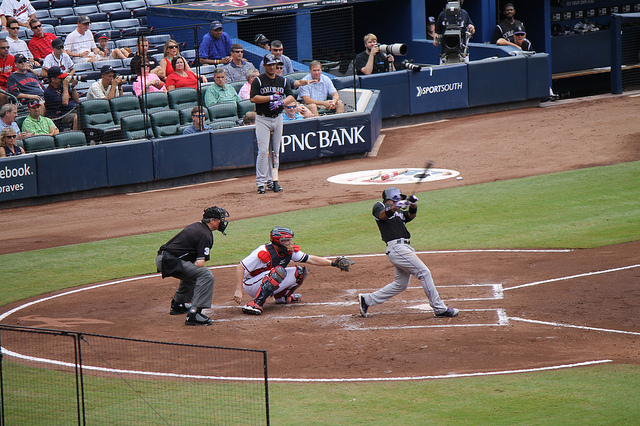Discuss the team dynamics and strategies that might be in play in this scenario. In this scenario, team dynamics and strategy are crucial. The offensive team's hitter is attempting to make good contact with the ball and reach base safely, ideally by hitting it where the fielders are not positioned. The defensive team's pitcher is utilizing a strategy, often dictated by the catcher's signals, to throw a pitch that will either result in a swing and miss or a poorly hit ball. Fielders must be prepared to react quickly to any balls hit into play, coordinating their movements to either catch fly balls or field ground balls efficiently to throw runners out. Teams also utilize various formations and shift positions depending on the hitter's tendencies, a strategy that involves analysis and prediction of player behaviors. 